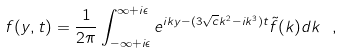<formula> <loc_0><loc_0><loc_500><loc_500>f ( y , t ) = \frac { 1 } { 2 \pi } \int _ { - \infty + i \epsilon } ^ { \infty + i \epsilon } e ^ { i k y - ( 3 \sqrt { c } k ^ { 2 } - i k ^ { 3 } ) t } \tilde { f } ( k ) d k \ ,</formula> 